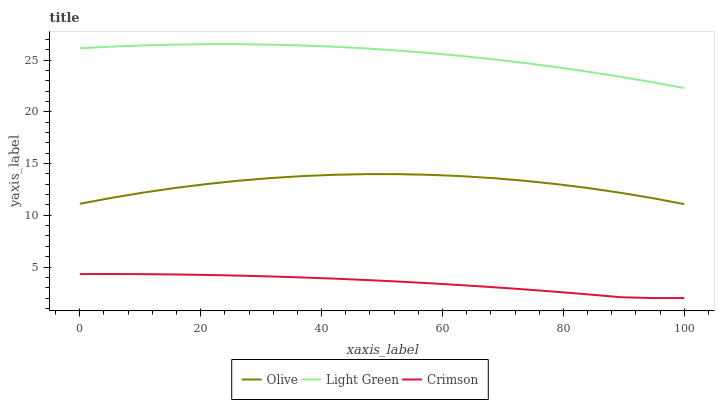Does Crimson have the minimum area under the curve?
Answer yes or no. Yes. Does Light Green have the maximum area under the curve?
Answer yes or no. Yes. Does Light Green have the minimum area under the curve?
Answer yes or no. No. Does Crimson have the maximum area under the curve?
Answer yes or no. No. Is Crimson the smoothest?
Answer yes or no. Yes. Is Olive the roughest?
Answer yes or no. Yes. Is Light Green the smoothest?
Answer yes or no. No. Is Light Green the roughest?
Answer yes or no. No. Does Crimson have the lowest value?
Answer yes or no. Yes. Does Light Green have the lowest value?
Answer yes or no. No. Does Light Green have the highest value?
Answer yes or no. Yes. Does Crimson have the highest value?
Answer yes or no. No. Is Crimson less than Olive?
Answer yes or no. Yes. Is Light Green greater than Olive?
Answer yes or no. Yes. Does Crimson intersect Olive?
Answer yes or no. No. 